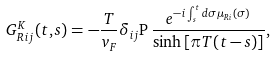Convert formula to latex. <formula><loc_0><loc_0><loc_500><loc_500>G _ { R \, i j } ^ { K } ( t , s ) = - \frac { T } { v _ { F } } \delta _ { i j } { \mathrm P } \, \frac { e ^ { - i \int _ { s } ^ { t } d \sigma \mu _ { R i } ( \sigma ) } } { \sinh \left [ \pi T ( t - s ) \right ] } ,</formula> 